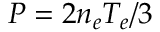Convert formula to latex. <formula><loc_0><loc_0><loc_500><loc_500>P = 2 n _ { e } T _ { e } / 3</formula> 